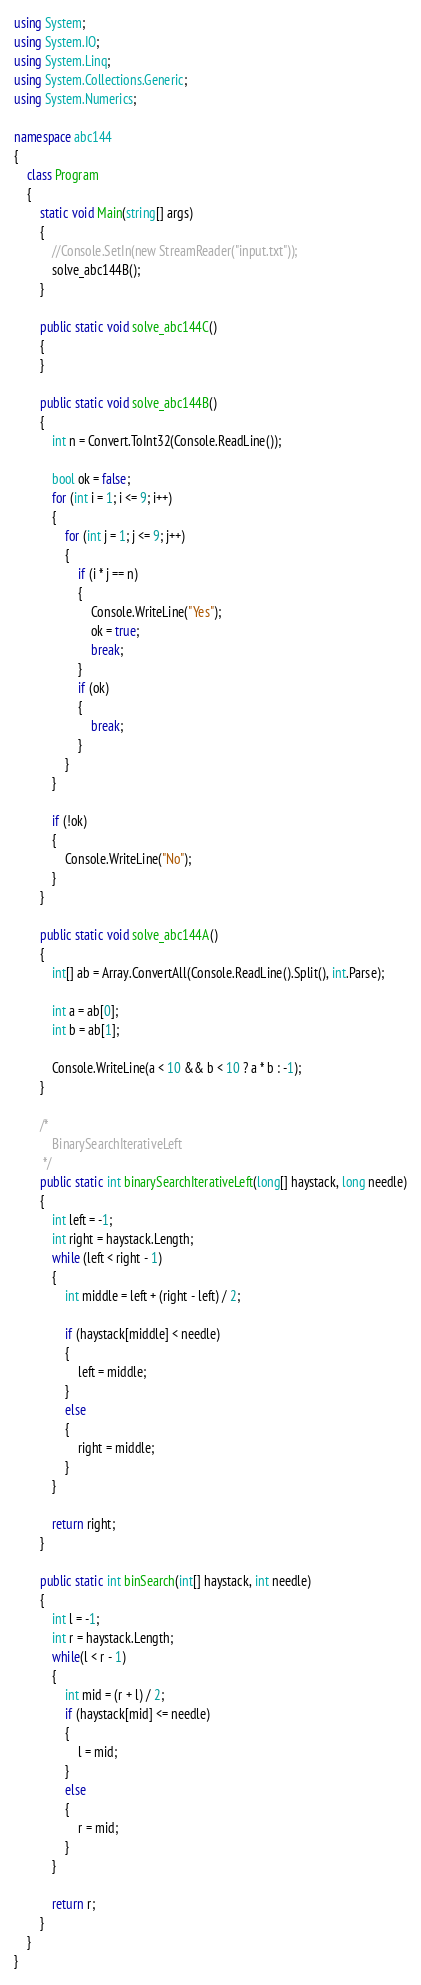<code> <loc_0><loc_0><loc_500><loc_500><_C#_>using System;
using System.IO;
using System.Linq;
using System.Collections.Generic;
using System.Numerics;

namespace abc144
{
    class Program
    {
        static void Main(string[] args)
        {
            //Console.SetIn(new StreamReader("input.txt"));
            solve_abc144B();
        }

        public static void solve_abc144C()
        {
        }

        public static void solve_abc144B()
        {
            int n = Convert.ToInt32(Console.ReadLine());

            bool ok = false;
            for (int i = 1; i <= 9; i++)
            {
                for (int j = 1; j <= 9; j++)
                {
                    if (i * j == n)
                    {
                        Console.WriteLine("Yes");
                        ok = true;
                        break;
                    }
                    if (ok)
                    {
                        break;
                    }
                }
            }

            if (!ok)
            {
                Console.WriteLine("No");
            }
        }

        public static void solve_abc144A()
        {
            int[] ab = Array.ConvertAll(Console.ReadLine().Split(), int.Parse);

            int a = ab[0];
            int b = ab[1];

            Console.WriteLine(a < 10 && b < 10 ? a * b : -1);
        }

        /*
            BinarySearchIterativeLeft
         */
        public static int binarySearchIterativeLeft(long[] haystack, long needle)
        {
            int left = -1;
            int right = haystack.Length;
            while (left < right - 1)
            {
                int middle = left + (right - left) / 2;
 
                if (haystack[middle] < needle)
                {
                    left = middle;
                }
                else
                {
                    right = middle;
                }
            }
 
            return right;
        }
        
        public static int binSearch(int[] haystack, int needle)
        {
            int l = -1;
            int r = haystack.Length;
            while(l < r - 1)
            {
                int mid = (r + l) / 2;
                if (haystack[mid] <= needle)
                {
                    l = mid;
                }
                else 
                {
                    r = mid;
                }
            }
 
            return r;
        }                        
    }
}
</code> 